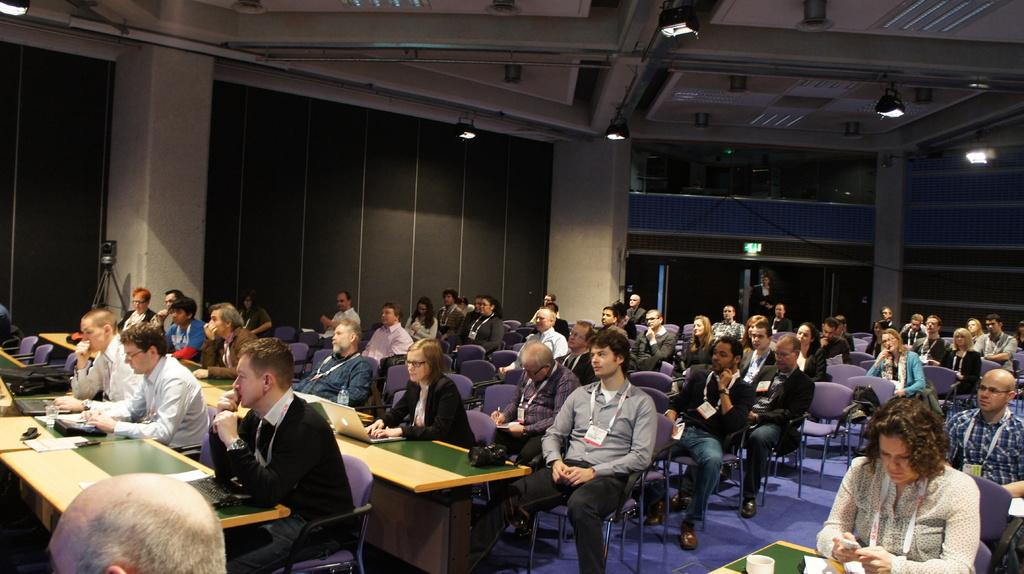How many people are in the image? There is a group of people in the image. What are the people doing in the image? The people are sitting on chairs. What can be seen on the tables in the image? There are laptops, papers, cups, and tissues on the tables. Are there any other objects on the tables? Yes, there are other objects on the tables. What can be seen in the image besides the people and objects on the tables? There are lights in the image. What type of road can be seen in the image? There is no road present in the image. How many weeks have passed since the people in the image last met? The image does not provide any information about the passage of time or the frequency of meetings between the people. --- Facts: 1. There is a car in the image. 2. The car is parked on the street. 3. There are trees on the street. 4. There are other cars parked on the street. 5. There are streetlights on the street. 6. There is a sidewalk on the street. Absurd Topics: bird, ocean, mountain Conversation: What is the main subject of the image? The main subject of the image is a car. Where is the car located in the image? The car is parked on the street. What else can be seen on the street in the image? There are trees, other cars, streetlights, and a sidewalk on the street. Reasoning: Let's think step by step in order to produce the conversation. We start by identifying the main subject in the image, which is the car. Then, we describe the car's location and the other objects and features present on the street, such as trees, other cars, streetlights, and a sidewalk. Each question is designed to elicit a specific detail about the image that is known from the provided facts. Absurd Question/Answer: Can you see any birds flying over the ocean in the image? There is no ocean or birds present in the image. Is there a mountain visible in the background of the image? There is no mountain visible in the image. 